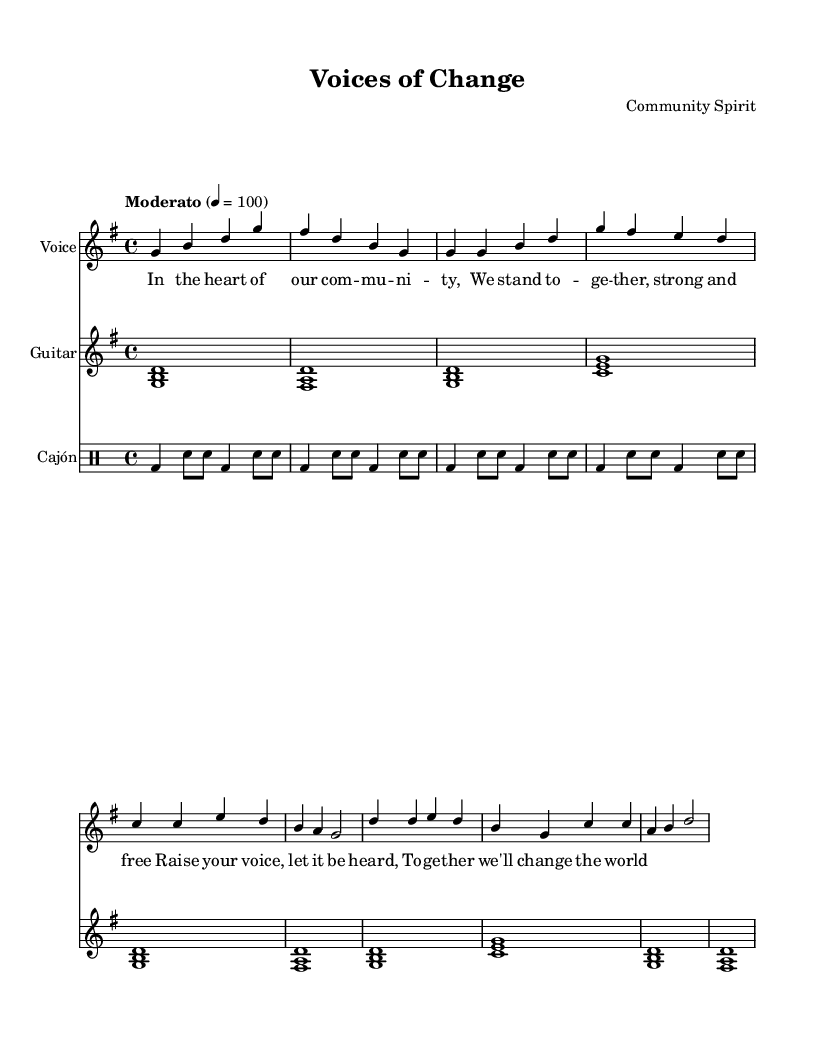What is the key signature of this music? The key signature is G major, which has one sharp (F#). This is indicated at the beginning of the staff where the key signature is placed.
Answer: G major What is the time signature of the piece? The time signature indicated at the beginning of the music is 4/4. This means there are four beats in each measure and the quarter note gets one beat.
Answer: 4/4 What is the tempo marking of the score? The tempo marking is "Moderato," which generally indicates a moderate pace of music. This is also noted at the beginning of the score.
Answer: Moderato How many measures are in the verse section? There are four measures in the verse section, as indicated by the grouping of the notes in the provided notation under the "Verse" label.
Answer: 4 What is the last chord of the chorus? The last chord of the chorus is a D major chord, as can be inferred from the notes D, A, and F# written together at the end of the chorus.
Answer: D major What lyrical theme is presented in the chorus? The theme presented in the chorus involves unity and activism, as evidenced by the phrase "together we'll change the world." This abstract concept is central to community resilience, reflecting the song's overall message.
Answer: Unity and activism How many instruments are featured in this piece? There are three instruments featured in this piece: voice, guitar, and cajón. The score clearly shows separate staves for each instrument with designated parts.
Answer: 3 